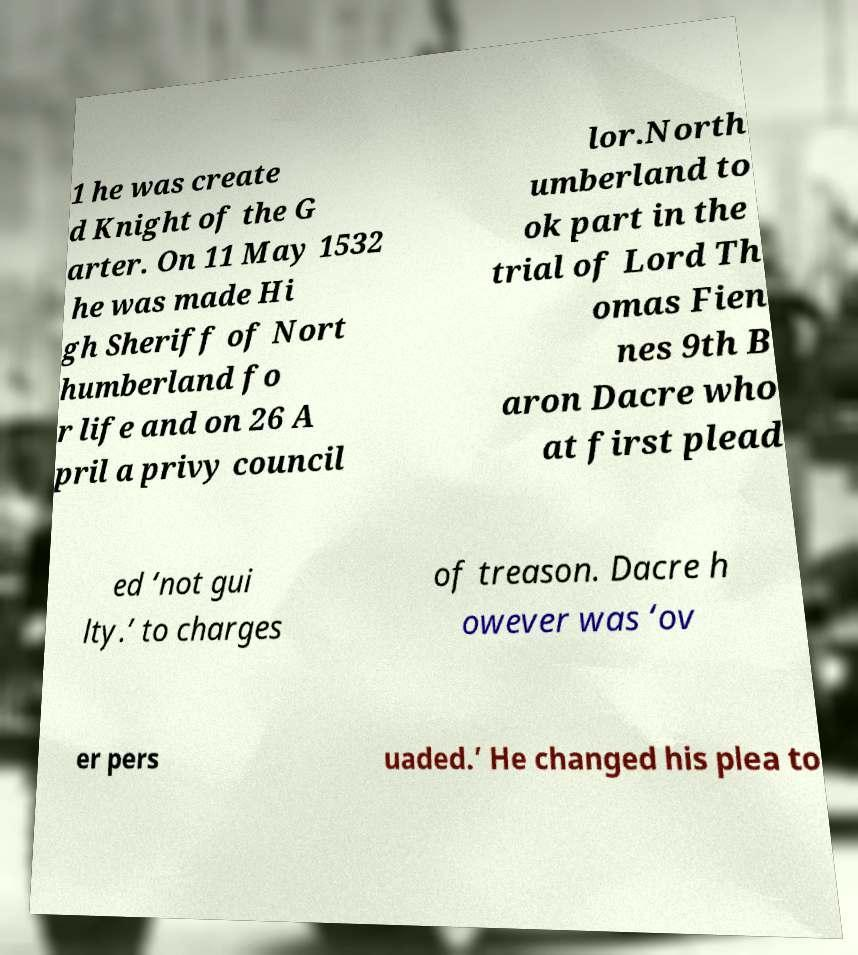I need the written content from this picture converted into text. Can you do that? 1 he was create d Knight of the G arter. On 11 May 1532 he was made Hi gh Sheriff of Nort humberland fo r life and on 26 A pril a privy council lor.North umberland to ok part in the trial of Lord Th omas Fien nes 9th B aron Dacre who at first plead ed ‘not gui lty.’ to charges of treason. Dacre h owever was ‘ov er pers uaded.’ He changed his plea to 